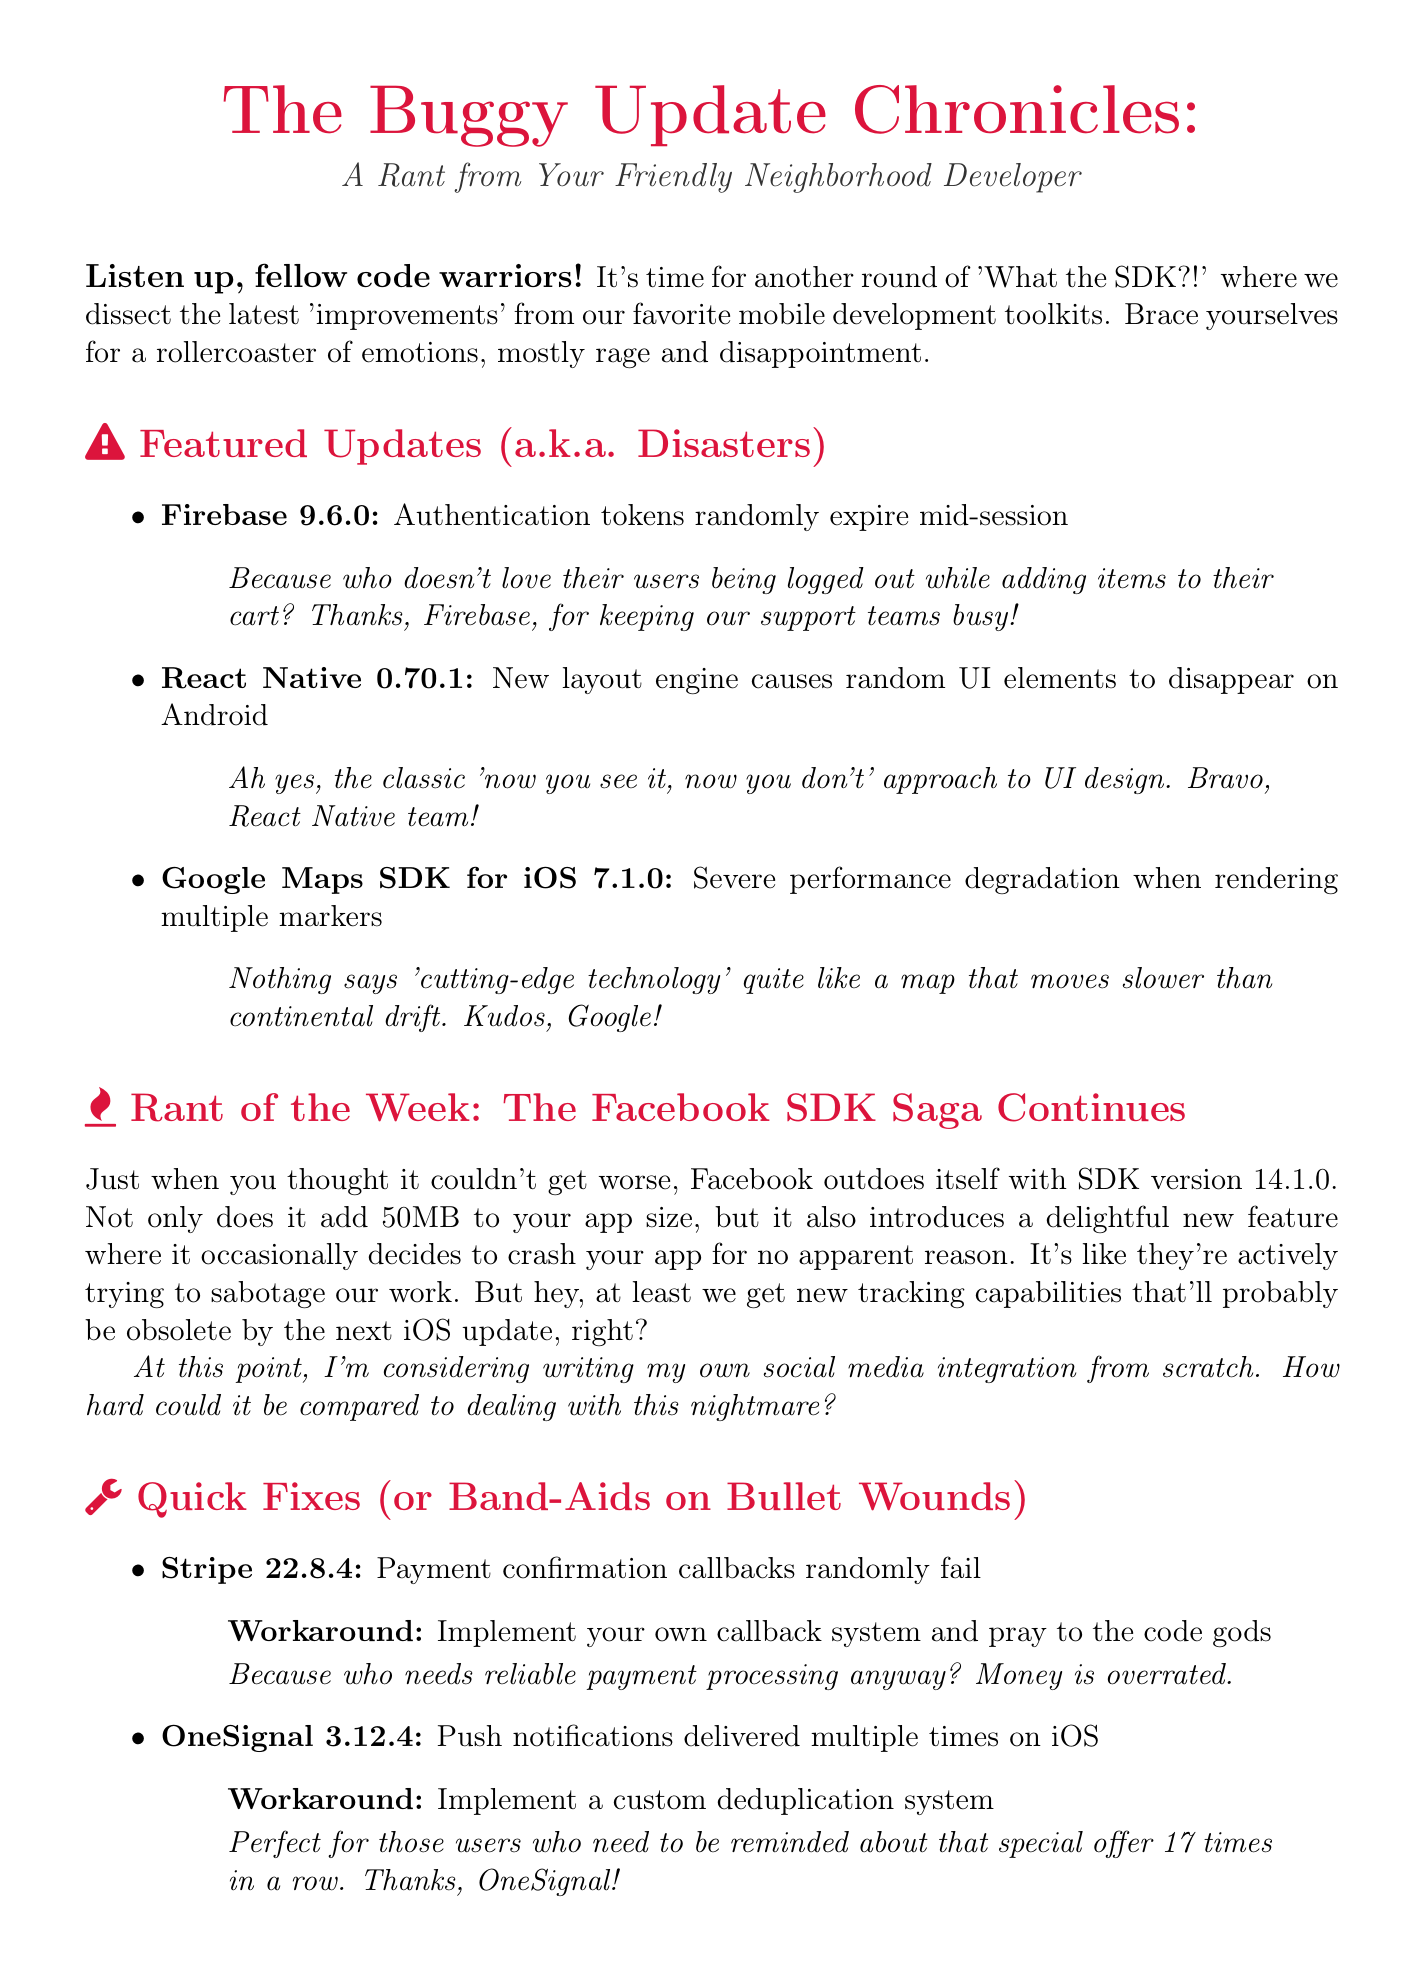What is the title of the newsletter? The title is stated at the beginning of the document.
Answer: The Buggy Update Chronicles: A Rant from Your Friendly Neighborhood Developer What is the version of Firebase causing issues? The document lists specific SDK versions next to their respective issues.
Answer: 9.6.0 What issue does React Native have in its latest update? The document mentions specific issues associated with each SDK update.
Answer: New layout engine causes random UI elements to disappear on Android What is the workaround for the Stripe SDK issue? The document provides suggested workarounds for the issues listed.
Answer: Implement your own callback system and pray to the code gods What is the rant of the week about? The section is clearly titled and summarized in the document.
Answer: The Facebook SDK Saga Continues How many push notifications does OneSignal send on iOS? The document mentions the issue related to push notifications.
Answer: Multiple times What feature does the Facebook SDK introduce in version 14.1.0? The document describes new features and their consequences for each SDK.
Answer: New tracking capabilities What color is used for the newsletter title? The document specifies color codes for certain text styles.
Answer: Angry red What should developers remember according to the closing thoughts? The closing thoughts summarize a key takeaway for readers.
Answer: We're just cursed with subpar tools 